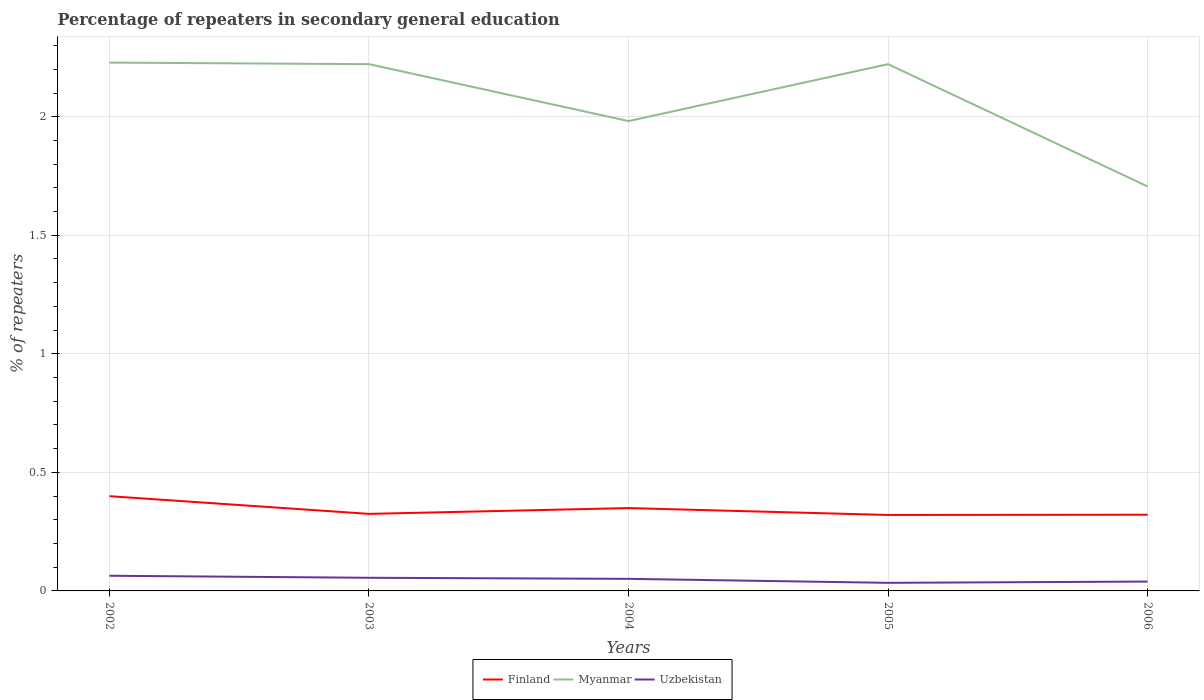Across all years, what is the maximum percentage of repeaters in secondary general education in Uzbekistan?
Make the answer very short. 0.03. In which year was the percentage of repeaters in secondary general education in Myanmar maximum?
Your response must be concise. 2006. What is the total percentage of repeaters in secondary general education in Finland in the graph?
Your answer should be compact. 0.08. What is the difference between the highest and the second highest percentage of repeaters in secondary general education in Uzbekistan?
Offer a terse response. 0.03. What is the difference between the highest and the lowest percentage of repeaters in secondary general education in Finland?
Give a very brief answer. 2. How many lines are there?
Your answer should be very brief. 3. How many years are there in the graph?
Give a very brief answer. 5. Does the graph contain grids?
Keep it short and to the point. Yes. Where does the legend appear in the graph?
Make the answer very short. Bottom center. How many legend labels are there?
Your answer should be compact. 3. What is the title of the graph?
Ensure brevity in your answer.  Percentage of repeaters in secondary general education. What is the label or title of the Y-axis?
Your response must be concise. % of repeaters. What is the % of repeaters in Finland in 2002?
Offer a terse response. 0.4. What is the % of repeaters in Myanmar in 2002?
Keep it short and to the point. 2.23. What is the % of repeaters in Uzbekistan in 2002?
Your answer should be very brief. 0.06. What is the % of repeaters of Finland in 2003?
Provide a succinct answer. 0.32. What is the % of repeaters of Myanmar in 2003?
Provide a short and direct response. 2.22. What is the % of repeaters of Uzbekistan in 2003?
Your answer should be very brief. 0.06. What is the % of repeaters of Finland in 2004?
Make the answer very short. 0.35. What is the % of repeaters in Myanmar in 2004?
Provide a succinct answer. 1.98. What is the % of repeaters in Uzbekistan in 2004?
Make the answer very short. 0.05. What is the % of repeaters of Finland in 2005?
Your answer should be compact. 0.32. What is the % of repeaters in Myanmar in 2005?
Keep it short and to the point. 2.22. What is the % of repeaters of Uzbekistan in 2005?
Ensure brevity in your answer.  0.03. What is the % of repeaters of Finland in 2006?
Keep it short and to the point. 0.32. What is the % of repeaters of Myanmar in 2006?
Your response must be concise. 1.71. What is the % of repeaters of Uzbekistan in 2006?
Give a very brief answer. 0.04. Across all years, what is the maximum % of repeaters in Finland?
Make the answer very short. 0.4. Across all years, what is the maximum % of repeaters of Myanmar?
Keep it short and to the point. 2.23. Across all years, what is the maximum % of repeaters of Uzbekistan?
Keep it short and to the point. 0.06. Across all years, what is the minimum % of repeaters in Finland?
Your response must be concise. 0.32. Across all years, what is the minimum % of repeaters in Myanmar?
Your response must be concise. 1.71. Across all years, what is the minimum % of repeaters of Uzbekistan?
Offer a terse response. 0.03. What is the total % of repeaters in Finland in the graph?
Make the answer very short. 1.72. What is the total % of repeaters in Myanmar in the graph?
Offer a very short reply. 10.36. What is the total % of repeaters in Uzbekistan in the graph?
Provide a short and direct response. 0.24. What is the difference between the % of repeaters of Finland in 2002 and that in 2003?
Your answer should be compact. 0.07. What is the difference between the % of repeaters in Myanmar in 2002 and that in 2003?
Give a very brief answer. 0.01. What is the difference between the % of repeaters in Uzbekistan in 2002 and that in 2003?
Keep it short and to the point. 0.01. What is the difference between the % of repeaters of Finland in 2002 and that in 2004?
Provide a short and direct response. 0.05. What is the difference between the % of repeaters of Myanmar in 2002 and that in 2004?
Your answer should be compact. 0.25. What is the difference between the % of repeaters of Uzbekistan in 2002 and that in 2004?
Your response must be concise. 0.01. What is the difference between the % of repeaters of Finland in 2002 and that in 2005?
Your response must be concise. 0.08. What is the difference between the % of repeaters of Myanmar in 2002 and that in 2005?
Ensure brevity in your answer.  0.01. What is the difference between the % of repeaters in Uzbekistan in 2002 and that in 2005?
Ensure brevity in your answer.  0.03. What is the difference between the % of repeaters of Finland in 2002 and that in 2006?
Offer a very short reply. 0.08. What is the difference between the % of repeaters in Myanmar in 2002 and that in 2006?
Provide a short and direct response. 0.52. What is the difference between the % of repeaters of Uzbekistan in 2002 and that in 2006?
Keep it short and to the point. 0.02. What is the difference between the % of repeaters of Finland in 2003 and that in 2004?
Your answer should be compact. -0.02. What is the difference between the % of repeaters in Myanmar in 2003 and that in 2004?
Give a very brief answer. 0.24. What is the difference between the % of repeaters in Uzbekistan in 2003 and that in 2004?
Offer a very short reply. 0. What is the difference between the % of repeaters of Finland in 2003 and that in 2005?
Keep it short and to the point. 0. What is the difference between the % of repeaters of Myanmar in 2003 and that in 2005?
Your answer should be compact. 0. What is the difference between the % of repeaters of Uzbekistan in 2003 and that in 2005?
Offer a very short reply. 0.02. What is the difference between the % of repeaters of Finland in 2003 and that in 2006?
Make the answer very short. 0. What is the difference between the % of repeaters in Myanmar in 2003 and that in 2006?
Your response must be concise. 0.52. What is the difference between the % of repeaters of Uzbekistan in 2003 and that in 2006?
Offer a terse response. 0.02. What is the difference between the % of repeaters of Finland in 2004 and that in 2005?
Provide a succinct answer. 0.03. What is the difference between the % of repeaters in Myanmar in 2004 and that in 2005?
Keep it short and to the point. -0.24. What is the difference between the % of repeaters of Uzbekistan in 2004 and that in 2005?
Your answer should be very brief. 0.02. What is the difference between the % of repeaters in Finland in 2004 and that in 2006?
Your response must be concise. 0.03. What is the difference between the % of repeaters in Myanmar in 2004 and that in 2006?
Your answer should be very brief. 0.28. What is the difference between the % of repeaters of Uzbekistan in 2004 and that in 2006?
Your response must be concise. 0.01. What is the difference between the % of repeaters of Finland in 2005 and that in 2006?
Offer a very short reply. -0. What is the difference between the % of repeaters in Myanmar in 2005 and that in 2006?
Give a very brief answer. 0.52. What is the difference between the % of repeaters of Uzbekistan in 2005 and that in 2006?
Your answer should be very brief. -0.01. What is the difference between the % of repeaters in Finland in 2002 and the % of repeaters in Myanmar in 2003?
Give a very brief answer. -1.82. What is the difference between the % of repeaters of Finland in 2002 and the % of repeaters of Uzbekistan in 2003?
Provide a short and direct response. 0.34. What is the difference between the % of repeaters in Myanmar in 2002 and the % of repeaters in Uzbekistan in 2003?
Make the answer very short. 2.17. What is the difference between the % of repeaters of Finland in 2002 and the % of repeaters of Myanmar in 2004?
Your answer should be very brief. -1.58. What is the difference between the % of repeaters in Finland in 2002 and the % of repeaters in Uzbekistan in 2004?
Your answer should be very brief. 0.35. What is the difference between the % of repeaters of Myanmar in 2002 and the % of repeaters of Uzbekistan in 2004?
Offer a terse response. 2.18. What is the difference between the % of repeaters of Finland in 2002 and the % of repeaters of Myanmar in 2005?
Offer a terse response. -1.82. What is the difference between the % of repeaters of Finland in 2002 and the % of repeaters of Uzbekistan in 2005?
Make the answer very short. 0.37. What is the difference between the % of repeaters of Myanmar in 2002 and the % of repeaters of Uzbekistan in 2005?
Your response must be concise. 2.19. What is the difference between the % of repeaters of Finland in 2002 and the % of repeaters of Myanmar in 2006?
Your response must be concise. -1.31. What is the difference between the % of repeaters in Finland in 2002 and the % of repeaters in Uzbekistan in 2006?
Provide a succinct answer. 0.36. What is the difference between the % of repeaters of Myanmar in 2002 and the % of repeaters of Uzbekistan in 2006?
Ensure brevity in your answer.  2.19. What is the difference between the % of repeaters of Finland in 2003 and the % of repeaters of Myanmar in 2004?
Keep it short and to the point. -1.66. What is the difference between the % of repeaters of Finland in 2003 and the % of repeaters of Uzbekistan in 2004?
Your answer should be compact. 0.27. What is the difference between the % of repeaters in Myanmar in 2003 and the % of repeaters in Uzbekistan in 2004?
Offer a very short reply. 2.17. What is the difference between the % of repeaters of Finland in 2003 and the % of repeaters of Myanmar in 2005?
Your response must be concise. -1.9. What is the difference between the % of repeaters of Finland in 2003 and the % of repeaters of Uzbekistan in 2005?
Offer a terse response. 0.29. What is the difference between the % of repeaters of Myanmar in 2003 and the % of repeaters of Uzbekistan in 2005?
Your answer should be compact. 2.19. What is the difference between the % of repeaters of Finland in 2003 and the % of repeaters of Myanmar in 2006?
Make the answer very short. -1.38. What is the difference between the % of repeaters in Finland in 2003 and the % of repeaters in Uzbekistan in 2006?
Your answer should be compact. 0.29. What is the difference between the % of repeaters in Myanmar in 2003 and the % of repeaters in Uzbekistan in 2006?
Provide a short and direct response. 2.18. What is the difference between the % of repeaters of Finland in 2004 and the % of repeaters of Myanmar in 2005?
Provide a succinct answer. -1.87. What is the difference between the % of repeaters of Finland in 2004 and the % of repeaters of Uzbekistan in 2005?
Keep it short and to the point. 0.32. What is the difference between the % of repeaters in Myanmar in 2004 and the % of repeaters in Uzbekistan in 2005?
Your response must be concise. 1.95. What is the difference between the % of repeaters of Finland in 2004 and the % of repeaters of Myanmar in 2006?
Your answer should be compact. -1.36. What is the difference between the % of repeaters in Finland in 2004 and the % of repeaters in Uzbekistan in 2006?
Keep it short and to the point. 0.31. What is the difference between the % of repeaters of Myanmar in 2004 and the % of repeaters of Uzbekistan in 2006?
Your answer should be compact. 1.94. What is the difference between the % of repeaters of Finland in 2005 and the % of repeaters of Myanmar in 2006?
Your answer should be very brief. -1.39. What is the difference between the % of repeaters of Finland in 2005 and the % of repeaters of Uzbekistan in 2006?
Your answer should be compact. 0.28. What is the difference between the % of repeaters of Myanmar in 2005 and the % of repeaters of Uzbekistan in 2006?
Offer a terse response. 2.18. What is the average % of repeaters in Finland per year?
Ensure brevity in your answer.  0.34. What is the average % of repeaters in Myanmar per year?
Give a very brief answer. 2.07. What is the average % of repeaters in Uzbekistan per year?
Give a very brief answer. 0.05. In the year 2002, what is the difference between the % of repeaters in Finland and % of repeaters in Myanmar?
Keep it short and to the point. -1.83. In the year 2002, what is the difference between the % of repeaters of Finland and % of repeaters of Uzbekistan?
Your answer should be compact. 0.34. In the year 2002, what is the difference between the % of repeaters in Myanmar and % of repeaters in Uzbekistan?
Ensure brevity in your answer.  2.16. In the year 2003, what is the difference between the % of repeaters of Finland and % of repeaters of Myanmar?
Offer a terse response. -1.9. In the year 2003, what is the difference between the % of repeaters in Finland and % of repeaters in Uzbekistan?
Keep it short and to the point. 0.27. In the year 2003, what is the difference between the % of repeaters of Myanmar and % of repeaters of Uzbekistan?
Give a very brief answer. 2.17. In the year 2004, what is the difference between the % of repeaters in Finland and % of repeaters in Myanmar?
Provide a succinct answer. -1.63. In the year 2004, what is the difference between the % of repeaters of Finland and % of repeaters of Uzbekistan?
Offer a very short reply. 0.3. In the year 2004, what is the difference between the % of repeaters in Myanmar and % of repeaters in Uzbekistan?
Your answer should be compact. 1.93. In the year 2005, what is the difference between the % of repeaters of Finland and % of repeaters of Myanmar?
Offer a very short reply. -1.9. In the year 2005, what is the difference between the % of repeaters of Finland and % of repeaters of Uzbekistan?
Offer a terse response. 0.29. In the year 2005, what is the difference between the % of repeaters in Myanmar and % of repeaters in Uzbekistan?
Make the answer very short. 2.19. In the year 2006, what is the difference between the % of repeaters of Finland and % of repeaters of Myanmar?
Ensure brevity in your answer.  -1.38. In the year 2006, what is the difference between the % of repeaters of Finland and % of repeaters of Uzbekistan?
Keep it short and to the point. 0.28. In the year 2006, what is the difference between the % of repeaters in Myanmar and % of repeaters in Uzbekistan?
Your answer should be very brief. 1.67. What is the ratio of the % of repeaters in Finland in 2002 to that in 2003?
Your response must be concise. 1.23. What is the ratio of the % of repeaters of Myanmar in 2002 to that in 2003?
Your answer should be compact. 1. What is the ratio of the % of repeaters of Uzbekistan in 2002 to that in 2003?
Give a very brief answer. 1.16. What is the ratio of the % of repeaters in Finland in 2002 to that in 2004?
Offer a very short reply. 1.14. What is the ratio of the % of repeaters in Myanmar in 2002 to that in 2004?
Offer a terse response. 1.12. What is the ratio of the % of repeaters of Uzbekistan in 2002 to that in 2004?
Keep it short and to the point. 1.26. What is the ratio of the % of repeaters in Finland in 2002 to that in 2005?
Provide a succinct answer. 1.25. What is the ratio of the % of repeaters in Uzbekistan in 2002 to that in 2005?
Give a very brief answer. 1.87. What is the ratio of the % of repeaters of Finland in 2002 to that in 2006?
Keep it short and to the point. 1.24. What is the ratio of the % of repeaters of Myanmar in 2002 to that in 2006?
Give a very brief answer. 1.31. What is the ratio of the % of repeaters in Uzbekistan in 2002 to that in 2006?
Your answer should be compact. 1.62. What is the ratio of the % of repeaters of Finland in 2003 to that in 2004?
Ensure brevity in your answer.  0.93. What is the ratio of the % of repeaters of Myanmar in 2003 to that in 2004?
Your answer should be compact. 1.12. What is the ratio of the % of repeaters in Uzbekistan in 2003 to that in 2004?
Give a very brief answer. 1.09. What is the ratio of the % of repeaters in Finland in 2003 to that in 2005?
Your answer should be compact. 1.01. What is the ratio of the % of repeaters of Myanmar in 2003 to that in 2005?
Your answer should be compact. 1. What is the ratio of the % of repeaters in Uzbekistan in 2003 to that in 2005?
Your response must be concise. 1.62. What is the ratio of the % of repeaters in Finland in 2003 to that in 2006?
Provide a short and direct response. 1.01. What is the ratio of the % of repeaters in Myanmar in 2003 to that in 2006?
Provide a succinct answer. 1.3. What is the ratio of the % of repeaters in Uzbekistan in 2003 to that in 2006?
Ensure brevity in your answer.  1.4. What is the ratio of the % of repeaters of Finland in 2004 to that in 2005?
Give a very brief answer. 1.09. What is the ratio of the % of repeaters in Myanmar in 2004 to that in 2005?
Give a very brief answer. 0.89. What is the ratio of the % of repeaters in Uzbekistan in 2004 to that in 2005?
Give a very brief answer. 1.49. What is the ratio of the % of repeaters in Finland in 2004 to that in 2006?
Your answer should be compact. 1.09. What is the ratio of the % of repeaters in Myanmar in 2004 to that in 2006?
Offer a terse response. 1.16. What is the ratio of the % of repeaters of Uzbekistan in 2004 to that in 2006?
Provide a succinct answer. 1.29. What is the ratio of the % of repeaters in Myanmar in 2005 to that in 2006?
Provide a succinct answer. 1.3. What is the ratio of the % of repeaters in Uzbekistan in 2005 to that in 2006?
Your response must be concise. 0.87. What is the difference between the highest and the second highest % of repeaters in Finland?
Your response must be concise. 0.05. What is the difference between the highest and the second highest % of repeaters of Myanmar?
Make the answer very short. 0.01. What is the difference between the highest and the second highest % of repeaters in Uzbekistan?
Offer a very short reply. 0.01. What is the difference between the highest and the lowest % of repeaters in Finland?
Make the answer very short. 0.08. What is the difference between the highest and the lowest % of repeaters in Myanmar?
Offer a terse response. 0.52. What is the difference between the highest and the lowest % of repeaters of Uzbekistan?
Make the answer very short. 0.03. 